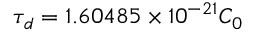Convert formula to latex. <formula><loc_0><loc_0><loc_500><loc_500>\tau _ { d } = 1 . 6 0 4 8 5 \times 1 0 ^ { - 2 1 } C _ { 0 }</formula> 